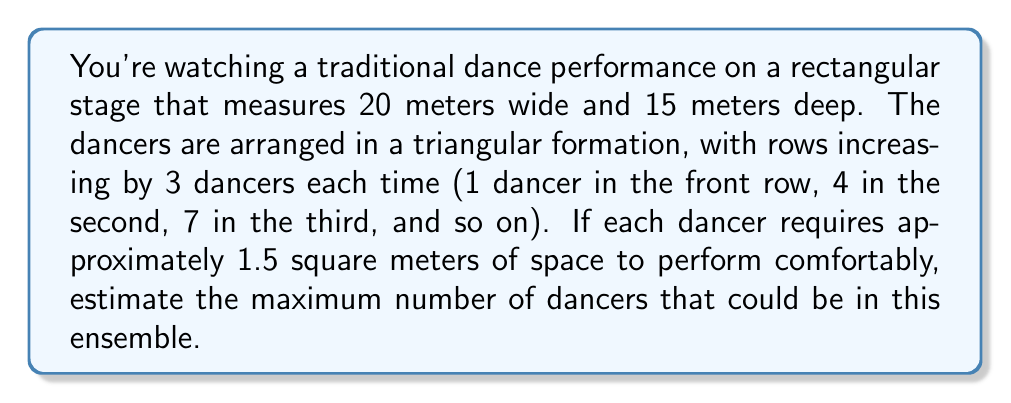What is the answer to this math problem? Let's approach this step-by-step:

1) First, calculate the total area of the stage:
   Area = width × depth = 20m × 15m = 300 m²

2) Now, let's consider the triangular formation. The number of dancers in each row follows the sequence: 1, 4, 7, 10, 13, ...
   This is an arithmetic sequence with a common difference of 3.

3) We can represent the nth term of this sequence as:
   $a_n = 1 + 3(n-1)$, where n is the row number.

4) The total number of dancers for n rows is the sum of this arithmetic sequence:
   $S_n = \frac{n}{2}[2a_1 + (n-1)d]$, where $a_1 = 1$ and $d = 3$

5) Substituting:
   $S_n = \frac{n}{2}[2(1) + (n-1)3] = \frac{n}{2}[2 + 3n - 3] = \frac{n(3n-1)}{2}$

6) Now, we need to find the largest n for which $S_n \times 1.5 \leq 300$
   (because each dancer needs 1.5 m² and the total area is 300 m²)

7) Solving this inequality:
   $\frac{n(3n-1)}{2} \times 1.5 \leq 300$
   $\frac{9n^2 - 3n}{4} \leq 200$
   $9n^2 - 3n - 800 \leq 0$

8) Solving this quadratic inequality:
   $n \approx 9.56$ or $n \approx -9.23$

9) Since n must be positive and an integer, the largest possible n is 9.

10) Therefore, the maximum number of dancers is:
    $S_9 = \frac{9(3 \times 9 - 1)}{2} = \frac{9(26)}{2} = 117$
Answer: 117 dancers 